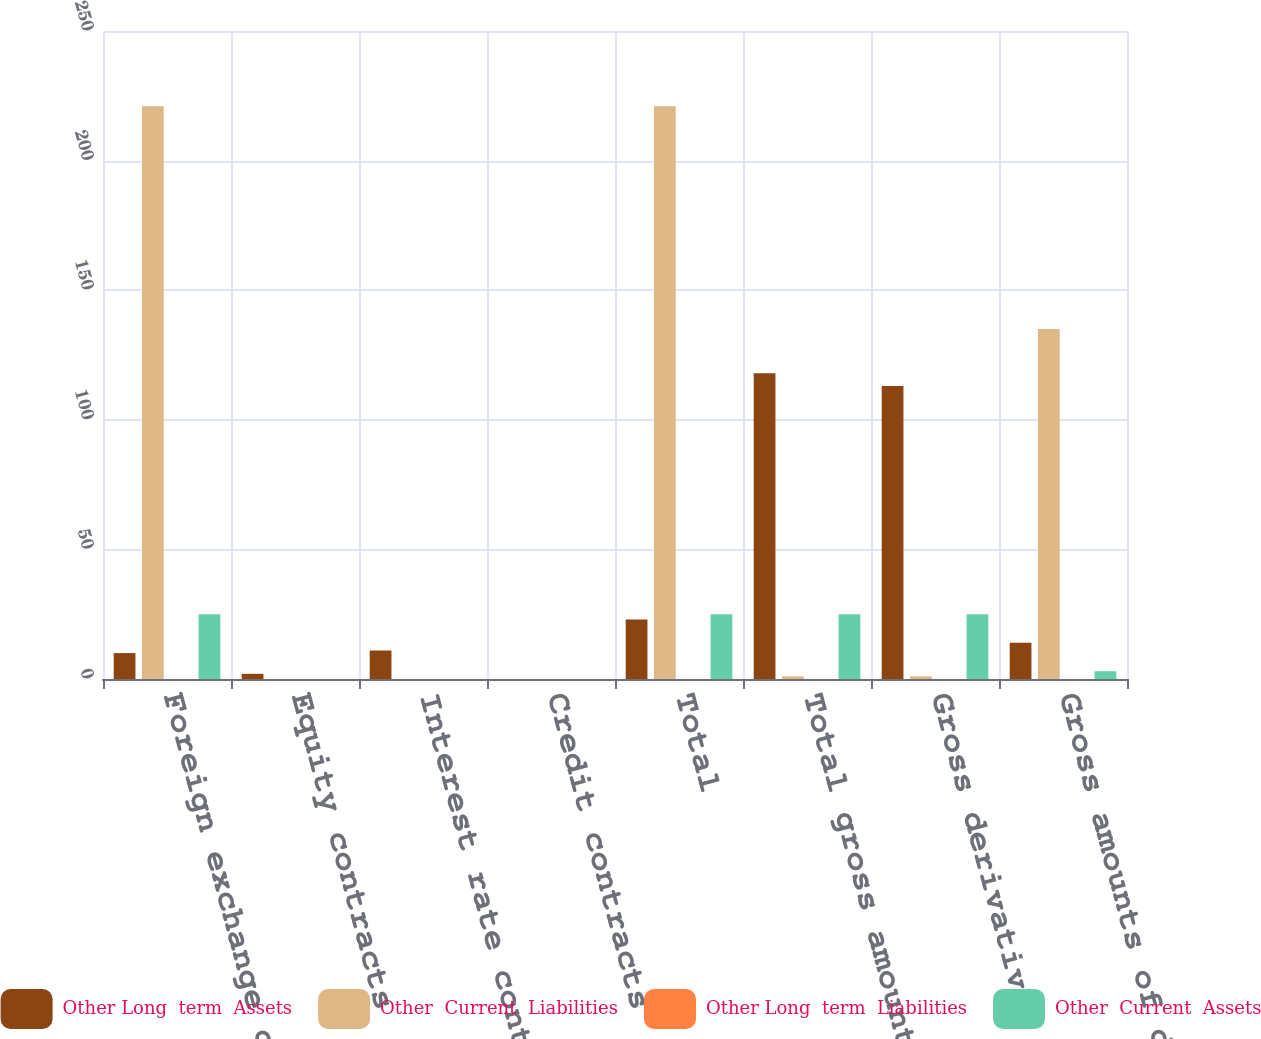Convert chart to OTSL. <chart><loc_0><loc_0><loc_500><loc_500><stacked_bar_chart><ecel><fcel>Foreign exchange contracts<fcel>Equity contracts<fcel>Interest rate contracts<fcel>Credit contracts<fcel>Total<fcel>Total gross amounts of<fcel>Gross derivatives either<fcel>Gross amounts of derivatives<nl><fcel>Other Long  term  Assets<fcel>10<fcel>2<fcel>11<fcel>0<fcel>23<fcel>118<fcel>113<fcel>14<nl><fcel>Other  Current  Liabilities<fcel>221<fcel>0<fcel>0<fcel>0<fcel>221<fcel>1<fcel>1<fcel>135<nl><fcel>Other Long  term  Liabilities<fcel>0<fcel>0<fcel>0<fcel>0<fcel>0<fcel>0<fcel>0<fcel>0<nl><fcel>Other  Current  Assets<fcel>25<fcel>0<fcel>0<fcel>0<fcel>25<fcel>25<fcel>25<fcel>3<nl></chart> 